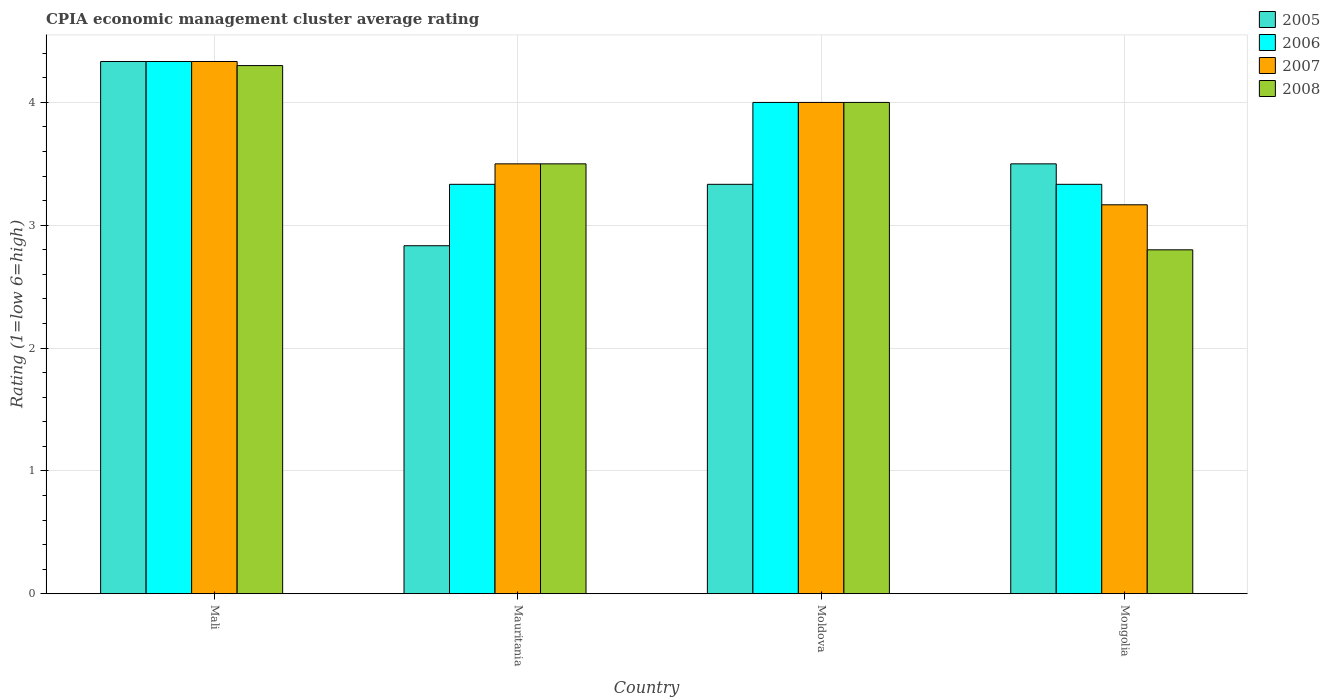How many different coloured bars are there?
Offer a terse response. 4. Are the number of bars per tick equal to the number of legend labels?
Provide a succinct answer. Yes. Are the number of bars on each tick of the X-axis equal?
Your answer should be compact. Yes. What is the label of the 3rd group of bars from the left?
Offer a very short reply. Moldova. What is the CPIA rating in 2007 in Moldova?
Your answer should be compact. 4. Across all countries, what is the maximum CPIA rating in 2005?
Give a very brief answer. 4.33. Across all countries, what is the minimum CPIA rating in 2006?
Give a very brief answer. 3.33. In which country was the CPIA rating in 2005 maximum?
Keep it short and to the point. Mali. In which country was the CPIA rating in 2006 minimum?
Your answer should be compact. Mauritania. What is the difference between the CPIA rating in 2008 in Mali and that in Moldova?
Make the answer very short. 0.3. What is the difference between the CPIA rating in 2007 in Mongolia and the CPIA rating in 2005 in Moldova?
Offer a very short reply. -0.17. What is the average CPIA rating in 2006 per country?
Provide a succinct answer. 3.75. What is the difference between the CPIA rating of/in 2006 and CPIA rating of/in 2007 in Mauritania?
Your answer should be very brief. -0.17. What is the difference between the highest and the second highest CPIA rating in 2007?
Give a very brief answer. -0.83. What is the difference between the highest and the lowest CPIA rating in 2008?
Your answer should be very brief. 1.5. Is the sum of the CPIA rating in 2005 in Mali and Moldova greater than the maximum CPIA rating in 2006 across all countries?
Provide a short and direct response. Yes. Is it the case that in every country, the sum of the CPIA rating in 2008 and CPIA rating in 2007 is greater than the sum of CPIA rating in 2005 and CPIA rating in 2006?
Provide a succinct answer. No. What does the 4th bar from the left in Mauritania represents?
Make the answer very short. 2008. What does the 4th bar from the right in Mongolia represents?
Provide a succinct answer. 2005. How many bars are there?
Provide a succinct answer. 16. How many countries are there in the graph?
Keep it short and to the point. 4. What is the difference between two consecutive major ticks on the Y-axis?
Your answer should be very brief. 1. Are the values on the major ticks of Y-axis written in scientific E-notation?
Provide a short and direct response. No. Does the graph contain any zero values?
Your answer should be compact. No. Does the graph contain grids?
Your response must be concise. Yes. How are the legend labels stacked?
Give a very brief answer. Vertical. What is the title of the graph?
Your response must be concise. CPIA economic management cluster average rating. Does "1977" appear as one of the legend labels in the graph?
Your response must be concise. No. What is the Rating (1=low 6=high) in 2005 in Mali?
Offer a very short reply. 4.33. What is the Rating (1=low 6=high) in 2006 in Mali?
Your answer should be very brief. 4.33. What is the Rating (1=low 6=high) of 2007 in Mali?
Make the answer very short. 4.33. What is the Rating (1=low 6=high) in 2005 in Mauritania?
Offer a terse response. 2.83. What is the Rating (1=low 6=high) in 2006 in Mauritania?
Make the answer very short. 3.33. What is the Rating (1=low 6=high) in 2007 in Mauritania?
Ensure brevity in your answer.  3.5. What is the Rating (1=low 6=high) in 2005 in Moldova?
Offer a very short reply. 3.33. What is the Rating (1=low 6=high) of 2006 in Moldova?
Offer a terse response. 4. What is the Rating (1=low 6=high) in 2007 in Moldova?
Offer a terse response. 4. What is the Rating (1=low 6=high) of 2005 in Mongolia?
Offer a very short reply. 3.5. What is the Rating (1=low 6=high) in 2006 in Mongolia?
Keep it short and to the point. 3.33. What is the Rating (1=low 6=high) in 2007 in Mongolia?
Ensure brevity in your answer.  3.17. What is the Rating (1=low 6=high) in 2008 in Mongolia?
Provide a succinct answer. 2.8. Across all countries, what is the maximum Rating (1=low 6=high) in 2005?
Provide a succinct answer. 4.33. Across all countries, what is the maximum Rating (1=low 6=high) in 2006?
Give a very brief answer. 4.33. Across all countries, what is the maximum Rating (1=low 6=high) in 2007?
Provide a short and direct response. 4.33. Across all countries, what is the minimum Rating (1=low 6=high) in 2005?
Provide a short and direct response. 2.83. Across all countries, what is the minimum Rating (1=low 6=high) in 2006?
Provide a succinct answer. 3.33. Across all countries, what is the minimum Rating (1=low 6=high) in 2007?
Ensure brevity in your answer.  3.17. Across all countries, what is the minimum Rating (1=low 6=high) in 2008?
Keep it short and to the point. 2.8. What is the total Rating (1=low 6=high) in 2005 in the graph?
Keep it short and to the point. 14. What is the total Rating (1=low 6=high) of 2007 in the graph?
Your response must be concise. 15. What is the total Rating (1=low 6=high) in 2008 in the graph?
Provide a short and direct response. 14.6. What is the difference between the Rating (1=low 6=high) of 2005 in Mali and that in Mauritania?
Give a very brief answer. 1.5. What is the difference between the Rating (1=low 6=high) in 2006 in Mali and that in Mauritania?
Your answer should be very brief. 1. What is the difference between the Rating (1=low 6=high) of 2008 in Mali and that in Moldova?
Your answer should be compact. 0.3. What is the difference between the Rating (1=low 6=high) in 2005 in Mali and that in Mongolia?
Ensure brevity in your answer.  0.83. What is the difference between the Rating (1=low 6=high) in 2006 in Mali and that in Mongolia?
Provide a short and direct response. 1. What is the difference between the Rating (1=low 6=high) in 2005 in Mauritania and that in Moldova?
Offer a terse response. -0.5. What is the difference between the Rating (1=low 6=high) of 2007 in Mauritania and that in Moldova?
Give a very brief answer. -0.5. What is the difference between the Rating (1=low 6=high) in 2008 in Mauritania and that in Moldova?
Offer a terse response. -0.5. What is the difference between the Rating (1=low 6=high) of 2005 in Mauritania and that in Mongolia?
Give a very brief answer. -0.67. What is the difference between the Rating (1=low 6=high) of 2006 in Mauritania and that in Mongolia?
Ensure brevity in your answer.  0. What is the difference between the Rating (1=low 6=high) in 2008 in Mauritania and that in Mongolia?
Keep it short and to the point. 0.7. What is the difference between the Rating (1=low 6=high) of 2005 in Moldova and that in Mongolia?
Your answer should be compact. -0.17. What is the difference between the Rating (1=low 6=high) in 2006 in Moldova and that in Mongolia?
Offer a terse response. 0.67. What is the difference between the Rating (1=low 6=high) of 2007 in Moldova and that in Mongolia?
Ensure brevity in your answer.  0.83. What is the difference between the Rating (1=low 6=high) in 2005 in Mali and the Rating (1=low 6=high) in 2008 in Mauritania?
Provide a short and direct response. 0.83. What is the difference between the Rating (1=low 6=high) in 2007 in Mali and the Rating (1=low 6=high) in 2008 in Mauritania?
Your response must be concise. 0.83. What is the difference between the Rating (1=low 6=high) in 2005 in Mali and the Rating (1=low 6=high) in 2006 in Moldova?
Your answer should be compact. 0.33. What is the difference between the Rating (1=low 6=high) of 2005 in Mali and the Rating (1=low 6=high) of 2007 in Moldova?
Provide a short and direct response. 0.33. What is the difference between the Rating (1=low 6=high) of 2005 in Mali and the Rating (1=low 6=high) of 2008 in Moldova?
Ensure brevity in your answer.  0.33. What is the difference between the Rating (1=low 6=high) in 2006 in Mali and the Rating (1=low 6=high) in 2007 in Moldova?
Offer a terse response. 0.33. What is the difference between the Rating (1=low 6=high) of 2006 in Mali and the Rating (1=low 6=high) of 2008 in Moldova?
Keep it short and to the point. 0.33. What is the difference between the Rating (1=low 6=high) of 2005 in Mali and the Rating (1=low 6=high) of 2007 in Mongolia?
Ensure brevity in your answer.  1.17. What is the difference between the Rating (1=low 6=high) in 2005 in Mali and the Rating (1=low 6=high) in 2008 in Mongolia?
Keep it short and to the point. 1.53. What is the difference between the Rating (1=low 6=high) of 2006 in Mali and the Rating (1=low 6=high) of 2008 in Mongolia?
Make the answer very short. 1.53. What is the difference between the Rating (1=low 6=high) in 2007 in Mali and the Rating (1=low 6=high) in 2008 in Mongolia?
Ensure brevity in your answer.  1.53. What is the difference between the Rating (1=low 6=high) of 2005 in Mauritania and the Rating (1=low 6=high) of 2006 in Moldova?
Your answer should be very brief. -1.17. What is the difference between the Rating (1=low 6=high) of 2005 in Mauritania and the Rating (1=low 6=high) of 2007 in Moldova?
Provide a succinct answer. -1.17. What is the difference between the Rating (1=low 6=high) in 2005 in Mauritania and the Rating (1=low 6=high) in 2008 in Moldova?
Ensure brevity in your answer.  -1.17. What is the difference between the Rating (1=low 6=high) in 2006 in Mauritania and the Rating (1=low 6=high) in 2008 in Moldova?
Ensure brevity in your answer.  -0.67. What is the difference between the Rating (1=low 6=high) in 2005 in Mauritania and the Rating (1=low 6=high) in 2006 in Mongolia?
Offer a very short reply. -0.5. What is the difference between the Rating (1=low 6=high) of 2006 in Mauritania and the Rating (1=low 6=high) of 2008 in Mongolia?
Keep it short and to the point. 0.53. What is the difference between the Rating (1=low 6=high) of 2007 in Mauritania and the Rating (1=low 6=high) of 2008 in Mongolia?
Your answer should be compact. 0.7. What is the difference between the Rating (1=low 6=high) in 2005 in Moldova and the Rating (1=low 6=high) in 2006 in Mongolia?
Make the answer very short. 0. What is the difference between the Rating (1=low 6=high) of 2005 in Moldova and the Rating (1=low 6=high) of 2008 in Mongolia?
Your response must be concise. 0.53. What is the difference between the Rating (1=low 6=high) in 2006 in Moldova and the Rating (1=low 6=high) in 2007 in Mongolia?
Your answer should be very brief. 0.83. What is the average Rating (1=low 6=high) of 2006 per country?
Your answer should be very brief. 3.75. What is the average Rating (1=low 6=high) of 2007 per country?
Keep it short and to the point. 3.75. What is the average Rating (1=low 6=high) of 2008 per country?
Provide a short and direct response. 3.65. What is the difference between the Rating (1=low 6=high) in 2006 and Rating (1=low 6=high) in 2008 in Mali?
Provide a short and direct response. 0.03. What is the difference between the Rating (1=low 6=high) in 2005 and Rating (1=low 6=high) in 2006 in Mauritania?
Provide a succinct answer. -0.5. What is the difference between the Rating (1=low 6=high) in 2005 and Rating (1=low 6=high) in 2007 in Mauritania?
Make the answer very short. -0.67. What is the difference between the Rating (1=low 6=high) in 2007 and Rating (1=low 6=high) in 2008 in Mauritania?
Your response must be concise. 0. What is the difference between the Rating (1=low 6=high) in 2005 and Rating (1=low 6=high) in 2006 in Moldova?
Provide a short and direct response. -0.67. What is the difference between the Rating (1=low 6=high) in 2005 and Rating (1=low 6=high) in 2008 in Moldova?
Give a very brief answer. -0.67. What is the difference between the Rating (1=low 6=high) in 2007 and Rating (1=low 6=high) in 2008 in Moldova?
Your answer should be very brief. 0. What is the difference between the Rating (1=low 6=high) in 2005 and Rating (1=low 6=high) in 2007 in Mongolia?
Keep it short and to the point. 0.33. What is the difference between the Rating (1=low 6=high) of 2005 and Rating (1=low 6=high) of 2008 in Mongolia?
Give a very brief answer. 0.7. What is the difference between the Rating (1=low 6=high) of 2006 and Rating (1=low 6=high) of 2007 in Mongolia?
Provide a short and direct response. 0.17. What is the difference between the Rating (1=low 6=high) of 2006 and Rating (1=low 6=high) of 2008 in Mongolia?
Make the answer very short. 0.53. What is the difference between the Rating (1=low 6=high) of 2007 and Rating (1=low 6=high) of 2008 in Mongolia?
Provide a succinct answer. 0.37. What is the ratio of the Rating (1=low 6=high) of 2005 in Mali to that in Mauritania?
Your answer should be very brief. 1.53. What is the ratio of the Rating (1=low 6=high) of 2007 in Mali to that in Mauritania?
Ensure brevity in your answer.  1.24. What is the ratio of the Rating (1=low 6=high) in 2008 in Mali to that in Mauritania?
Ensure brevity in your answer.  1.23. What is the ratio of the Rating (1=low 6=high) in 2005 in Mali to that in Moldova?
Make the answer very short. 1.3. What is the ratio of the Rating (1=low 6=high) of 2008 in Mali to that in Moldova?
Offer a terse response. 1.07. What is the ratio of the Rating (1=low 6=high) of 2005 in Mali to that in Mongolia?
Offer a terse response. 1.24. What is the ratio of the Rating (1=low 6=high) in 2006 in Mali to that in Mongolia?
Your response must be concise. 1.3. What is the ratio of the Rating (1=low 6=high) in 2007 in Mali to that in Mongolia?
Offer a terse response. 1.37. What is the ratio of the Rating (1=low 6=high) in 2008 in Mali to that in Mongolia?
Provide a succinct answer. 1.54. What is the ratio of the Rating (1=low 6=high) of 2005 in Mauritania to that in Moldova?
Provide a short and direct response. 0.85. What is the ratio of the Rating (1=low 6=high) of 2007 in Mauritania to that in Moldova?
Your answer should be compact. 0.88. What is the ratio of the Rating (1=low 6=high) of 2008 in Mauritania to that in Moldova?
Offer a very short reply. 0.88. What is the ratio of the Rating (1=low 6=high) in 2005 in Mauritania to that in Mongolia?
Offer a terse response. 0.81. What is the ratio of the Rating (1=low 6=high) of 2007 in Mauritania to that in Mongolia?
Ensure brevity in your answer.  1.11. What is the ratio of the Rating (1=low 6=high) in 2008 in Mauritania to that in Mongolia?
Your response must be concise. 1.25. What is the ratio of the Rating (1=low 6=high) in 2005 in Moldova to that in Mongolia?
Ensure brevity in your answer.  0.95. What is the ratio of the Rating (1=low 6=high) in 2007 in Moldova to that in Mongolia?
Offer a terse response. 1.26. What is the ratio of the Rating (1=low 6=high) of 2008 in Moldova to that in Mongolia?
Your answer should be compact. 1.43. What is the difference between the highest and the second highest Rating (1=low 6=high) of 2006?
Make the answer very short. 0.33. What is the difference between the highest and the second highest Rating (1=low 6=high) of 2008?
Give a very brief answer. 0.3. What is the difference between the highest and the lowest Rating (1=low 6=high) of 2005?
Provide a succinct answer. 1.5. What is the difference between the highest and the lowest Rating (1=low 6=high) in 2006?
Offer a very short reply. 1. What is the difference between the highest and the lowest Rating (1=low 6=high) in 2007?
Your answer should be very brief. 1.17. What is the difference between the highest and the lowest Rating (1=low 6=high) of 2008?
Make the answer very short. 1.5. 